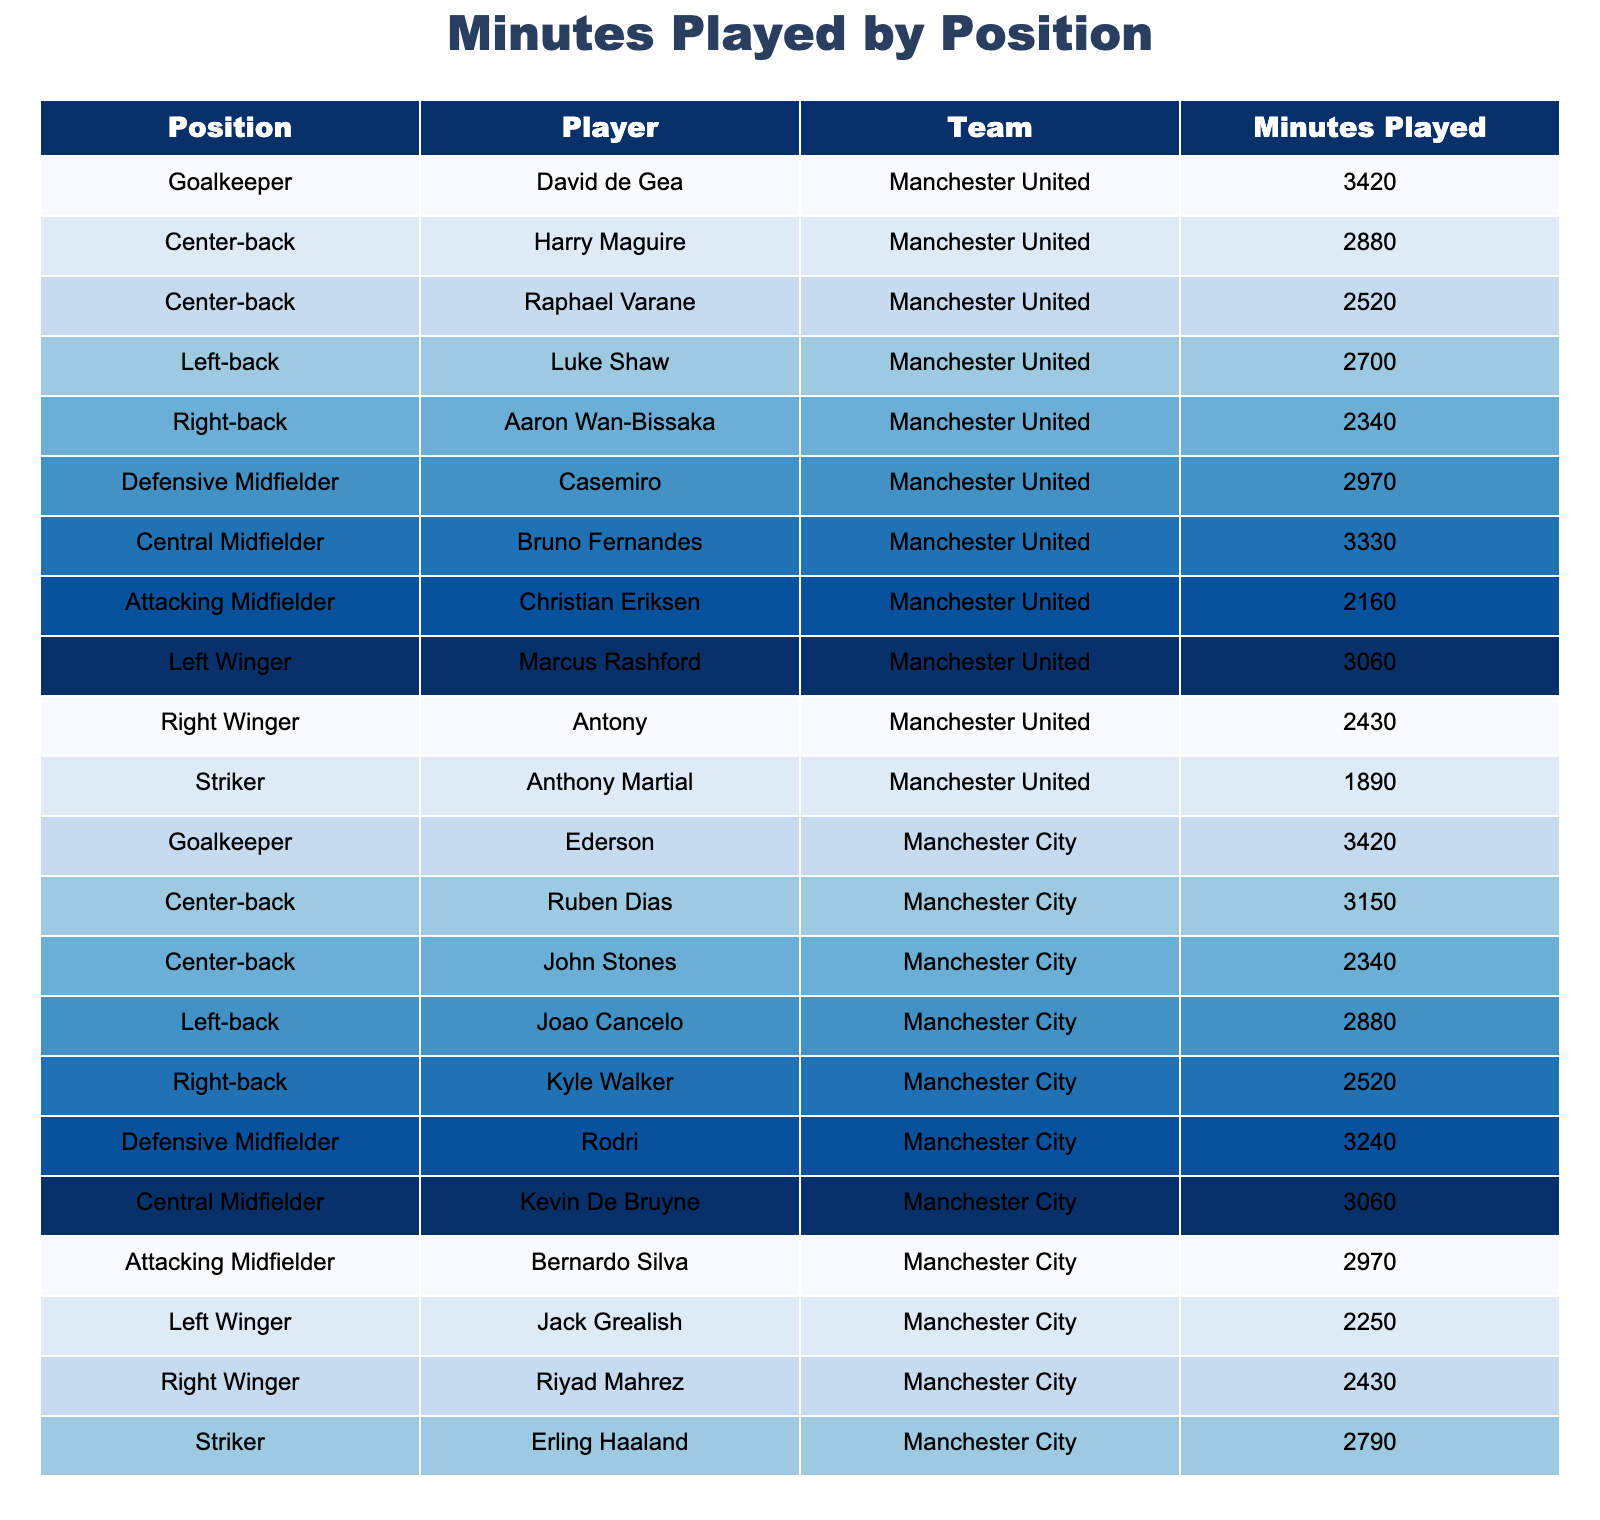What position played the most minutes for Manchester United? By looking at the table, the player with the most minutes played is David de Gea, the goalkeeper, with 3420 minutes.
Answer: David de Gea How many minutes did the Central Midfielder of Manchester City play? The Central Midfielder for Manchester City is Kevin De Bruyne, and his played minutes are listed as 3060.
Answer: 3060 What’s the total number of minutes played by all players in Manchester City’s starting lineup? To find the total minutes for Manchester City, we add up the minutes for all players: 3420 + 3150 + 2340 + 2880 + 2520 + 3240 + 3060 + 2970 + 2250 + 2430 + 2790 = 30360.
Answer: 30360 Did any player in the table play more than 3000 minutes? By scanning through the table, yes, several players like David de Gea, Harry Maguire, and Rodri played more than 3000 minutes.
Answer: Yes Which position had the least playing time in Manchester United? Looking at Manchester United, Anthony Martial as the striker had the least minutes at 1890.
Answer: Striker What is the average minutes played by the Manchester City defenders? The defenders for Manchester City are Ruben Dias, John Stones, Joao Cancelo, and Kyle Walker with minutes 3150, 2340, 2880, and 2520 respectively. Their average is calculated as (3150 + 2340 + 2880 + 2520) / 4 = 2722.5.
Answer: 2722.5 Which team had a player in the attacking midfielder position with the lowest minutes played? By checking both teams, Christian Eriksen for Manchester United had 2160 minutes, while Bernardo Silva for Manchester City had 2970 minutes. Thus, Manchester United has the lowest minutes for the attacking midfielder position.
Answer: Manchester United How many more minutes did the goalkeeper for Manchester City play compared to Manchester United? David de Gea played 3420 minutes and Ederson also played 3420 minutes. There is no difference; it's a tie at 0 minutes more.
Answer: 0 What is the total number of minutes played by Strikers in both teams? The strikers are Anthony Martial from Manchester United with 1890 minutes and Erling Haaland from Manchester City with 2790 minutes. Adding them gives 1890 + 2790 = 4680.
Answer: 4680 Which position has the maximum total minutes played across both teams? Summing the minutes played by all players in each position will reveal that the goalkeeper position has the highest total with both de Gea and Ederson at 3420 minutes each, totaling 6840 minutes.
Answer: Goalkeeper 